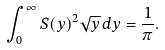<formula> <loc_0><loc_0><loc_500><loc_500>\int _ { 0 } ^ { \infty } S ( y ) ^ { 2 } \sqrt { y } \, d y = \frac { 1 } { \pi } .</formula> 